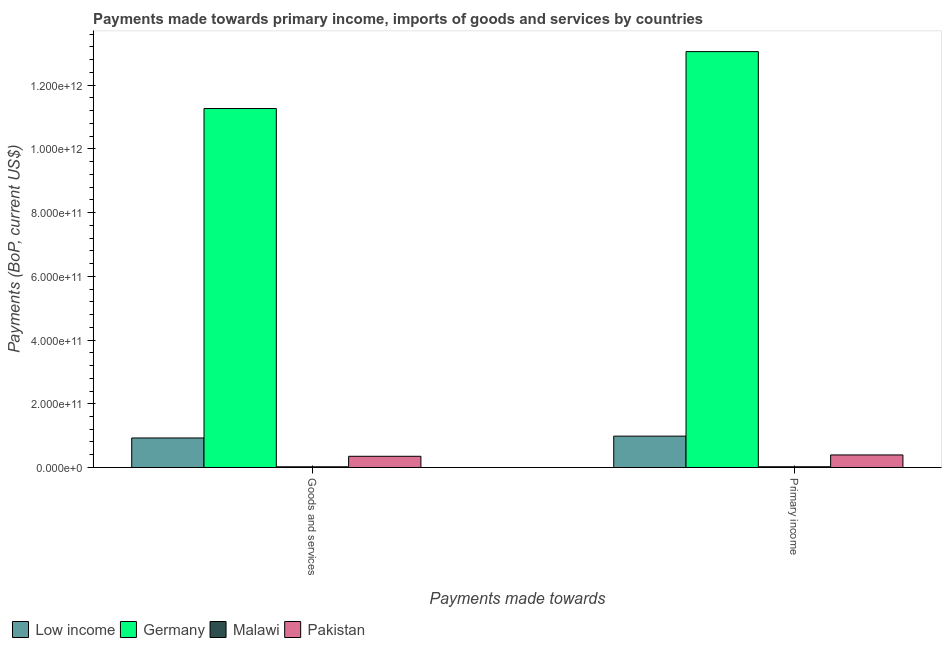Are the number of bars per tick equal to the number of legend labels?
Make the answer very short. Yes. How many bars are there on the 2nd tick from the left?
Offer a terse response. 4. How many bars are there on the 2nd tick from the right?
Ensure brevity in your answer.  4. What is the label of the 2nd group of bars from the left?
Keep it short and to the point. Primary income. What is the payments made towards goods and services in Pakistan?
Make the answer very short. 3.52e+1. Across all countries, what is the maximum payments made towards primary income?
Ensure brevity in your answer.  1.31e+12. Across all countries, what is the minimum payments made towards primary income?
Give a very brief answer. 2.30e+09. In which country was the payments made towards primary income maximum?
Your response must be concise. Germany. In which country was the payments made towards goods and services minimum?
Keep it short and to the point. Malawi. What is the total payments made towards goods and services in the graph?
Offer a very short reply. 1.26e+12. What is the difference between the payments made towards goods and services in Low income and that in Germany?
Offer a terse response. -1.03e+12. What is the difference between the payments made towards goods and services in Pakistan and the payments made towards primary income in Low income?
Offer a terse response. -6.32e+1. What is the average payments made towards primary income per country?
Give a very brief answer. 3.61e+11. What is the difference between the payments made towards goods and services and payments made towards primary income in Low income?
Your answer should be compact. -5.75e+09. In how many countries, is the payments made towards primary income greater than 1160000000000 US$?
Offer a terse response. 1. What is the ratio of the payments made towards primary income in Low income to that in Germany?
Your response must be concise. 0.08. Is the payments made towards primary income in Low income less than that in Malawi?
Your answer should be very brief. No. How many bars are there?
Provide a succinct answer. 8. Are all the bars in the graph horizontal?
Make the answer very short. No. How many countries are there in the graph?
Provide a succinct answer. 4. What is the difference between two consecutive major ticks on the Y-axis?
Your answer should be very brief. 2.00e+11. Does the graph contain any zero values?
Give a very brief answer. No. What is the title of the graph?
Your response must be concise. Payments made towards primary income, imports of goods and services by countries. What is the label or title of the X-axis?
Make the answer very short. Payments made towards. What is the label or title of the Y-axis?
Your answer should be very brief. Payments (BoP, current US$). What is the Payments (BoP, current US$) of Low income in Goods and services?
Offer a terse response. 9.26e+1. What is the Payments (BoP, current US$) of Germany in Goods and services?
Offer a terse response. 1.13e+12. What is the Payments (BoP, current US$) of Malawi in Goods and services?
Your response must be concise. 2.18e+09. What is the Payments (BoP, current US$) of Pakistan in Goods and services?
Keep it short and to the point. 3.52e+1. What is the Payments (BoP, current US$) of Low income in Primary income?
Your answer should be compact. 9.84e+1. What is the Payments (BoP, current US$) in Germany in Primary income?
Provide a succinct answer. 1.31e+12. What is the Payments (BoP, current US$) in Malawi in Primary income?
Your answer should be very brief. 2.30e+09. What is the Payments (BoP, current US$) in Pakistan in Primary income?
Your answer should be very brief. 3.94e+1. Across all Payments made towards, what is the maximum Payments (BoP, current US$) in Low income?
Keep it short and to the point. 9.84e+1. Across all Payments made towards, what is the maximum Payments (BoP, current US$) of Germany?
Give a very brief answer. 1.31e+12. Across all Payments made towards, what is the maximum Payments (BoP, current US$) of Malawi?
Your answer should be compact. 2.30e+09. Across all Payments made towards, what is the maximum Payments (BoP, current US$) in Pakistan?
Provide a succinct answer. 3.94e+1. Across all Payments made towards, what is the minimum Payments (BoP, current US$) in Low income?
Your response must be concise. 9.26e+1. Across all Payments made towards, what is the minimum Payments (BoP, current US$) in Germany?
Provide a short and direct response. 1.13e+12. Across all Payments made towards, what is the minimum Payments (BoP, current US$) of Malawi?
Offer a very short reply. 2.18e+09. Across all Payments made towards, what is the minimum Payments (BoP, current US$) in Pakistan?
Offer a terse response. 3.52e+1. What is the total Payments (BoP, current US$) of Low income in the graph?
Your answer should be very brief. 1.91e+11. What is the total Payments (BoP, current US$) of Germany in the graph?
Give a very brief answer. 2.43e+12. What is the total Payments (BoP, current US$) in Malawi in the graph?
Offer a terse response. 4.47e+09. What is the total Payments (BoP, current US$) of Pakistan in the graph?
Ensure brevity in your answer.  7.45e+1. What is the difference between the Payments (BoP, current US$) in Low income in Goods and services and that in Primary income?
Offer a very short reply. -5.75e+09. What is the difference between the Payments (BoP, current US$) of Germany in Goods and services and that in Primary income?
Ensure brevity in your answer.  -1.79e+11. What is the difference between the Payments (BoP, current US$) of Malawi in Goods and services and that in Primary income?
Keep it short and to the point. -1.23e+08. What is the difference between the Payments (BoP, current US$) of Pakistan in Goods and services and that in Primary income?
Your response must be concise. -4.22e+09. What is the difference between the Payments (BoP, current US$) in Low income in Goods and services and the Payments (BoP, current US$) in Germany in Primary income?
Your response must be concise. -1.21e+12. What is the difference between the Payments (BoP, current US$) of Low income in Goods and services and the Payments (BoP, current US$) of Malawi in Primary income?
Keep it short and to the point. 9.03e+1. What is the difference between the Payments (BoP, current US$) of Low income in Goods and services and the Payments (BoP, current US$) of Pakistan in Primary income?
Ensure brevity in your answer.  5.33e+1. What is the difference between the Payments (BoP, current US$) in Germany in Goods and services and the Payments (BoP, current US$) in Malawi in Primary income?
Your answer should be compact. 1.12e+12. What is the difference between the Payments (BoP, current US$) in Germany in Goods and services and the Payments (BoP, current US$) in Pakistan in Primary income?
Keep it short and to the point. 1.09e+12. What is the difference between the Payments (BoP, current US$) of Malawi in Goods and services and the Payments (BoP, current US$) of Pakistan in Primary income?
Provide a succinct answer. -3.72e+1. What is the average Payments (BoP, current US$) in Low income per Payments made towards?
Make the answer very short. 9.55e+1. What is the average Payments (BoP, current US$) of Germany per Payments made towards?
Your answer should be compact. 1.22e+12. What is the average Payments (BoP, current US$) of Malawi per Payments made towards?
Provide a short and direct response. 2.24e+09. What is the average Payments (BoP, current US$) of Pakistan per Payments made towards?
Give a very brief answer. 3.73e+1. What is the difference between the Payments (BoP, current US$) in Low income and Payments (BoP, current US$) in Germany in Goods and services?
Ensure brevity in your answer.  -1.03e+12. What is the difference between the Payments (BoP, current US$) in Low income and Payments (BoP, current US$) in Malawi in Goods and services?
Keep it short and to the point. 9.05e+1. What is the difference between the Payments (BoP, current US$) of Low income and Payments (BoP, current US$) of Pakistan in Goods and services?
Provide a short and direct response. 5.75e+1. What is the difference between the Payments (BoP, current US$) of Germany and Payments (BoP, current US$) of Malawi in Goods and services?
Offer a terse response. 1.12e+12. What is the difference between the Payments (BoP, current US$) of Germany and Payments (BoP, current US$) of Pakistan in Goods and services?
Your answer should be very brief. 1.09e+12. What is the difference between the Payments (BoP, current US$) in Malawi and Payments (BoP, current US$) in Pakistan in Goods and services?
Offer a very short reply. -3.30e+1. What is the difference between the Payments (BoP, current US$) of Low income and Payments (BoP, current US$) of Germany in Primary income?
Your answer should be compact. -1.21e+12. What is the difference between the Payments (BoP, current US$) in Low income and Payments (BoP, current US$) in Malawi in Primary income?
Your answer should be compact. 9.61e+1. What is the difference between the Payments (BoP, current US$) in Low income and Payments (BoP, current US$) in Pakistan in Primary income?
Your answer should be very brief. 5.90e+1. What is the difference between the Payments (BoP, current US$) of Germany and Payments (BoP, current US$) of Malawi in Primary income?
Ensure brevity in your answer.  1.30e+12. What is the difference between the Payments (BoP, current US$) of Germany and Payments (BoP, current US$) of Pakistan in Primary income?
Provide a short and direct response. 1.27e+12. What is the difference between the Payments (BoP, current US$) in Malawi and Payments (BoP, current US$) in Pakistan in Primary income?
Offer a terse response. -3.71e+1. What is the ratio of the Payments (BoP, current US$) in Low income in Goods and services to that in Primary income?
Ensure brevity in your answer.  0.94. What is the ratio of the Payments (BoP, current US$) in Germany in Goods and services to that in Primary income?
Your answer should be compact. 0.86. What is the ratio of the Payments (BoP, current US$) in Malawi in Goods and services to that in Primary income?
Ensure brevity in your answer.  0.95. What is the ratio of the Payments (BoP, current US$) in Pakistan in Goods and services to that in Primary income?
Your answer should be very brief. 0.89. What is the difference between the highest and the second highest Payments (BoP, current US$) in Low income?
Keep it short and to the point. 5.75e+09. What is the difference between the highest and the second highest Payments (BoP, current US$) in Germany?
Ensure brevity in your answer.  1.79e+11. What is the difference between the highest and the second highest Payments (BoP, current US$) of Malawi?
Your answer should be very brief. 1.23e+08. What is the difference between the highest and the second highest Payments (BoP, current US$) of Pakistan?
Offer a terse response. 4.22e+09. What is the difference between the highest and the lowest Payments (BoP, current US$) of Low income?
Your answer should be very brief. 5.75e+09. What is the difference between the highest and the lowest Payments (BoP, current US$) of Germany?
Make the answer very short. 1.79e+11. What is the difference between the highest and the lowest Payments (BoP, current US$) of Malawi?
Your answer should be very brief. 1.23e+08. What is the difference between the highest and the lowest Payments (BoP, current US$) of Pakistan?
Provide a succinct answer. 4.22e+09. 